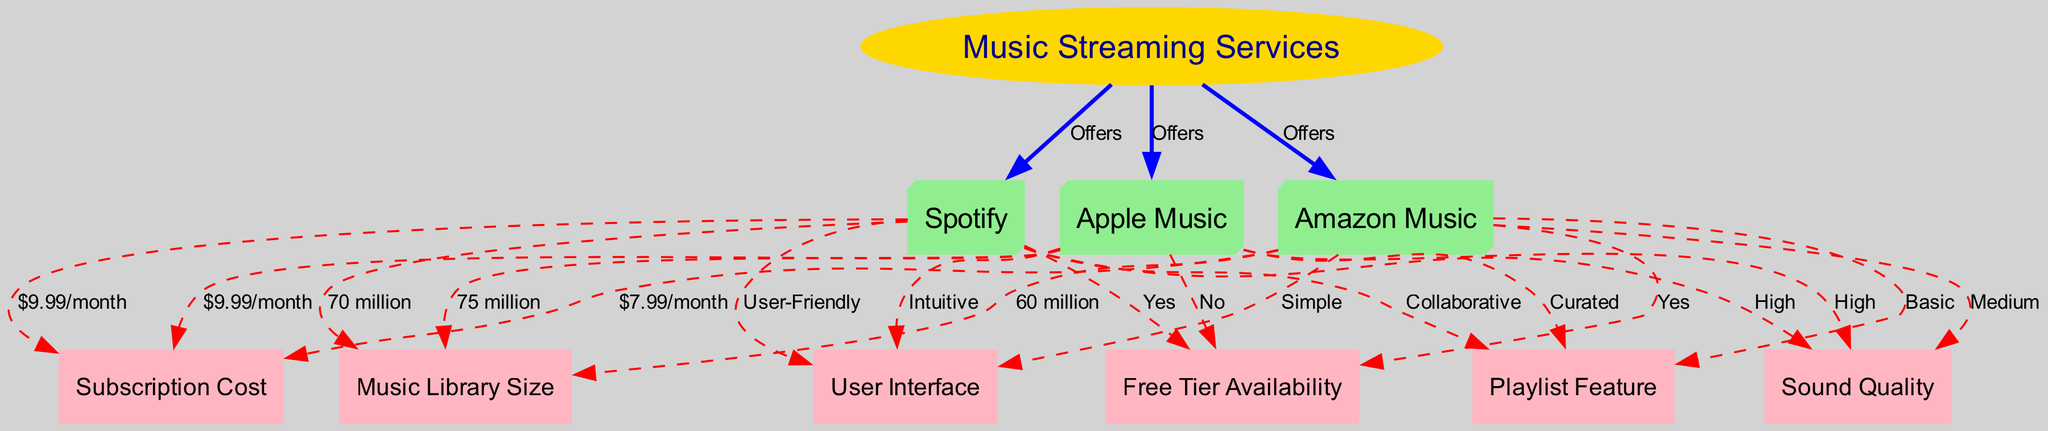What are the music streaming services compared in the diagram? The diagram lists three music streaming services: Spotify, Apple Music, and Amazon Music. This is derived from the nodes connected to the central node "Music Streaming Services."
Answer: Spotify, Apple Music, Amazon Music Which service offers a free tier? The diagram indicates that Spotify and Amazon Music have a "Yes" label connected to "Free Tier Availability," meaning they offer free tiers, while Apple Music does not.
Answer: Yes What is the subscription cost for Apple Music? The diagram shows a cost of "$9.99/month" connected to Apple Music, which is derived from the edge labeled "Subscription Cost."
Answer: $9.99/month Which service has the largest music library? According to the diagram, Apple Music has a music library size of "75 million," which is the highest among the three services listed (Spotify has 70 million, and Amazon Music has 60 million).
Answer: 75 million How does the sound quality of Amazon Music compare to Spotify? The diagram indicates that Spotify has "High" sound quality, while Amazon Music has "Medium" sound quality. This means that Spotify's sound quality is superior compared to Amazon Music's.
Answer: Medium What is the distinctive feature of Spotify's playlist capabilities? The diagram describes Spotify’s playlist feature as "Collaborative," meaning it can be edited or added to by multiple users, setting it apart from the other services.
Answer: Collaborative Which music streaming service is considered to have the most user-friendly interface? The diagram describes Spotify as "User-Friendly," which emphasizes its interface as the easiest to navigate among the listed services.
Answer: User-Friendly What type of playlists does Apple Music provide? The diagram connects Apple Music to the label "Curated," indicating that its playlists are primarily curated by experts rather than user-generated like in other services.
Answer: Curated How many nodes are there in the diagram? The total number of nodes includes the main service node plus the features and individual service nodes, which totals to ten distinct nodes in the diagram.
Answer: 10 